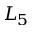Convert formula to latex. <formula><loc_0><loc_0><loc_500><loc_500>L _ { 5 }</formula> 